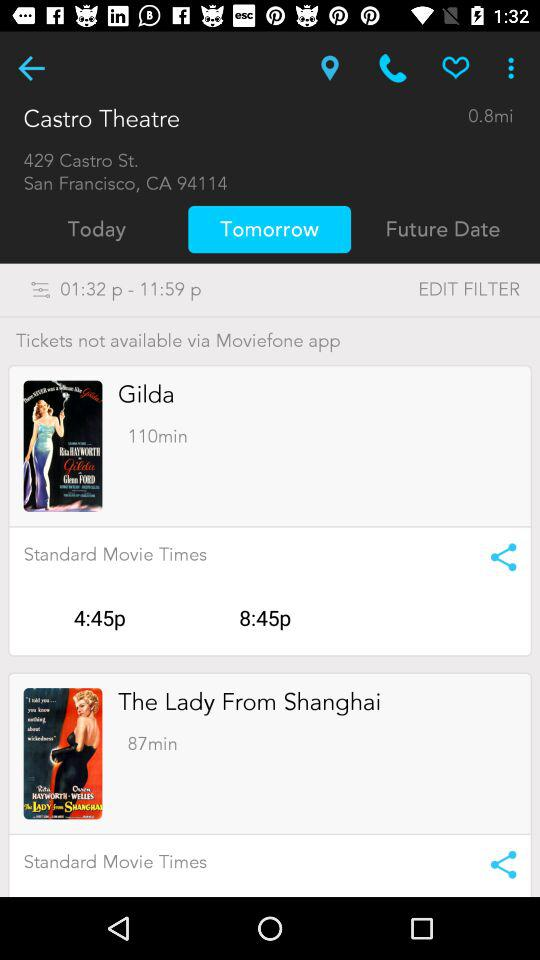How many more minutes are there between the earliest and latest showtime for the movie Gilda?
Answer the question using a single word or phrase. 4 